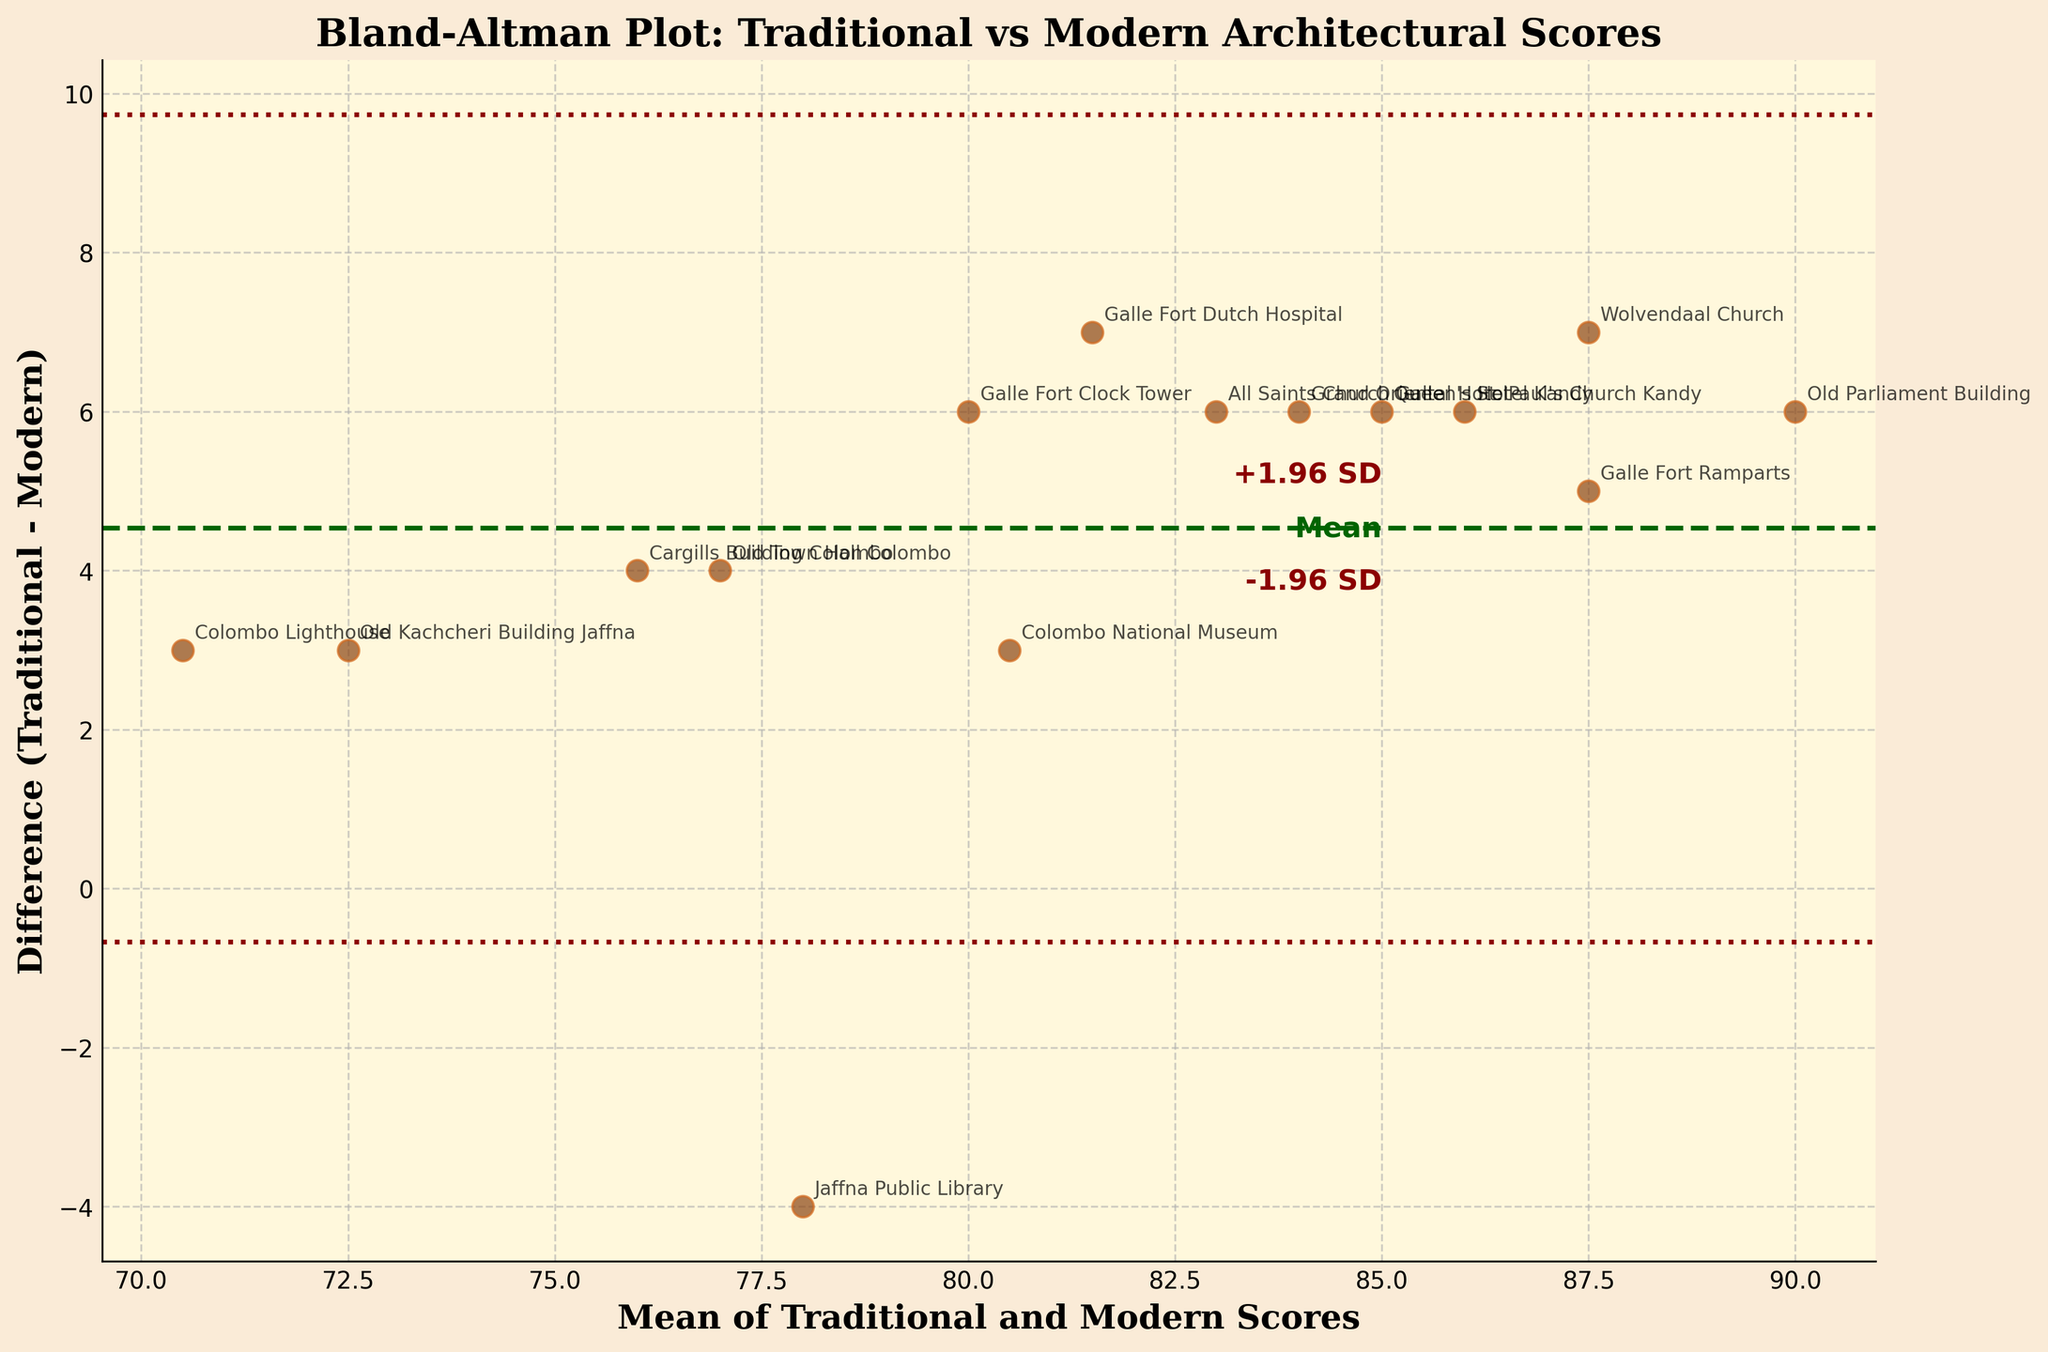What is the title of the plot? The title of the plot is usually found at the top of the figure in bold text. In this case, the title reads "Bland-Altman Plot: Traditional vs Modern Architectural Scores".
Answer: Bland-Altman Plot: Traditional vs Modern Architectural Scores What are the labels of the x and y axes? The x-axis label is "Mean of Traditional and Modern Scores" and the y-axis label is "Difference (Traditional - Modern)". These labels usually give context to what the axes represent.
Answer: Mean of Traditional and Modern Scores, Difference (Traditional - Modern) How many data points are plotted in the figure? The number of data points is equal to the number of different buildings evaluated, each represented by a scatter point in the plot. By counting, we notice there are 15 points.
Answer: 15 Which building has the smallest difference between Traditional and Modern Scores? This can be determined by looking at the point closest to the y-axis (difference close to zero). From the plot, the "Old Town Hall Colombo" appears to be the closest to the zero line.
Answer: Old Town Hall Colombo What is the mean difference (Traditional - Modern) line representing? The mean difference line represents the average difference between the Traditional and Modern scores of all buildings. It is depicted as a horizontal line across the plot and in this case, it's marked by the term "Mean".
Answer: Average difference What is the difference score for "Queen's Hotel Kandy"? Locate the data point labeled "Queen's Hotel Kandy" and read its y-value, which represents the difference score. Here, it is 6.
Answer: 6 Which buildings fall outside the ±1.96 SD limits? Identify data points that fall above or below the dotted lines depicting ±1.96 standard deviations from the mean difference. In this case, the "Wolvendaal Church" is above the upper limit, and the "Jaffna Public Library" is below the lower limit.
Answer: Wolvendaal Church, Jaffna Public Library What is the approximate mean score for "Galle Fort Clock Tower"? Find the "Galle Fort Clock Tower" on the plot. Its mean score is on the x-axis, roughly around 80 (midpoint of 83 and 77).
Answer: ~80 Is there a building with a difference of exactly 5? Look for a data point that intersects the y-value of 5. The "Colombo National Museum" appears to have this difference.
Answer: Colombo National Museum What does the scatter color and style signify? Scatter points are colored and styled uniformly suggesting each data point is part of the same comparison group (Traditional vs Modern scores). Colors, sizes, and edges enhance visual distinction but do not signify different categories.
Answer: Uniform comparison 